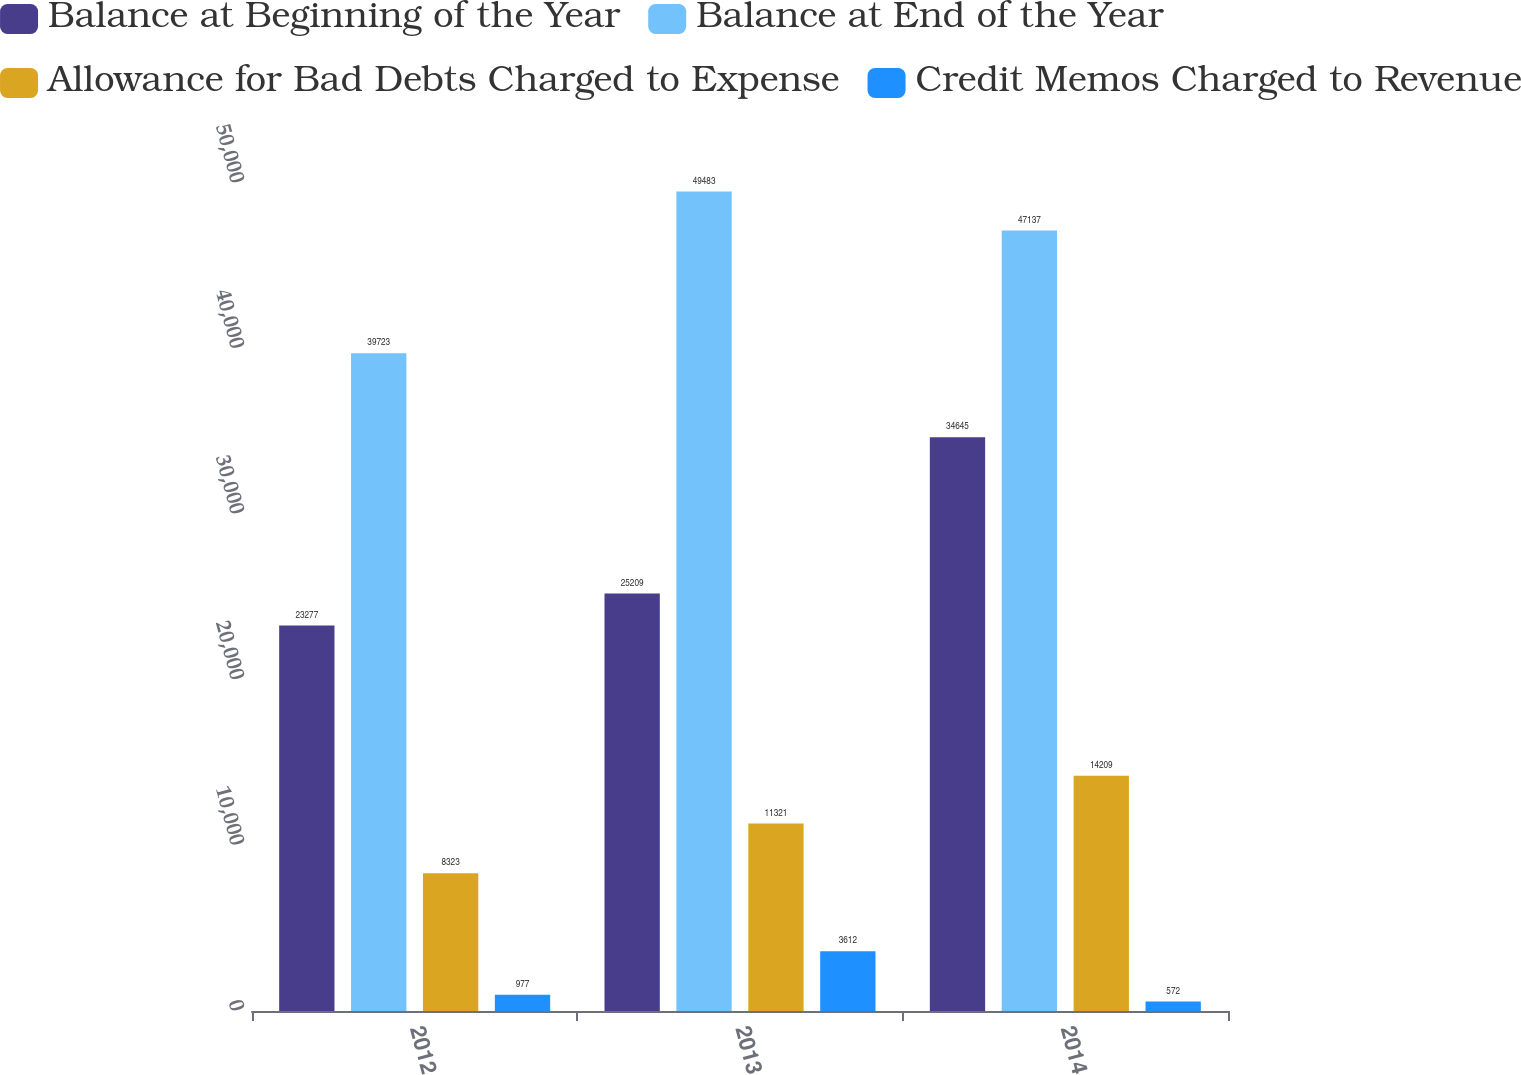<chart> <loc_0><loc_0><loc_500><loc_500><stacked_bar_chart><ecel><fcel>2012<fcel>2013<fcel>2014<nl><fcel>Balance at Beginning of the Year<fcel>23277<fcel>25209<fcel>34645<nl><fcel>Balance at End of the Year<fcel>39723<fcel>49483<fcel>47137<nl><fcel>Allowance for Bad Debts Charged to Expense<fcel>8323<fcel>11321<fcel>14209<nl><fcel>Credit Memos Charged to Revenue<fcel>977<fcel>3612<fcel>572<nl></chart> 